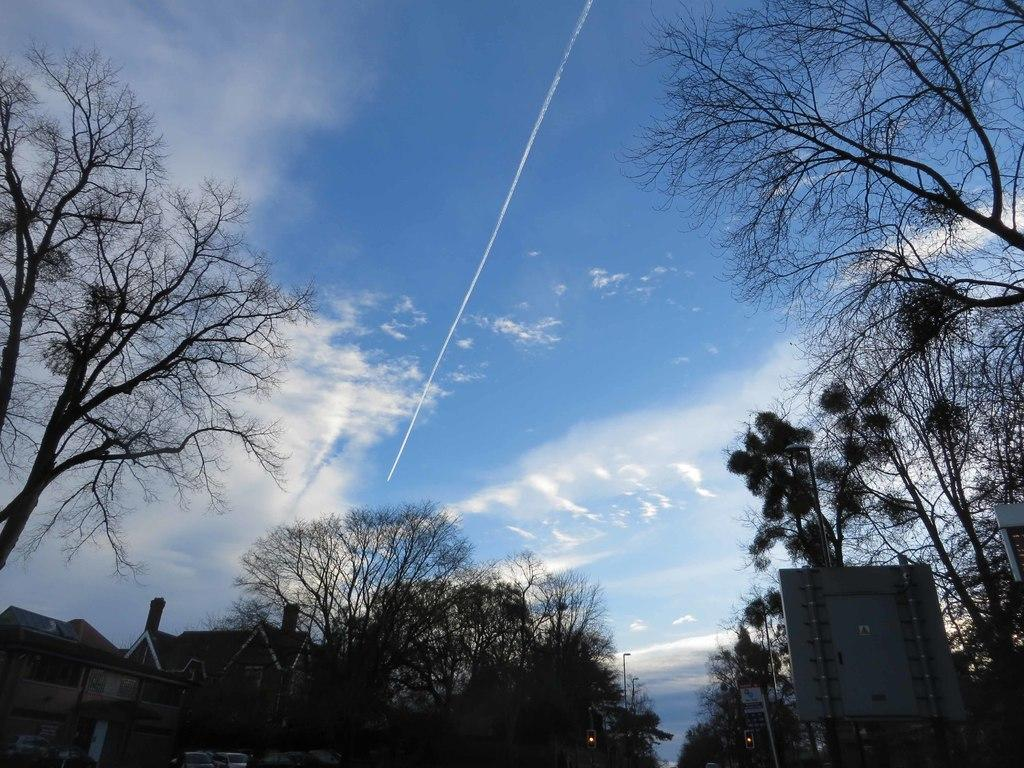What type of vegetation can be seen in the image? There are trees in the image. What type of structure is present in the image? There is a house in the image. What type of lighting is visible in the image? Street lights are visible in the image. What object can be seen in the image that might be used for displaying information or advertisements? There is a board in the image. What can be seen in the background of the image? The sky is visible in the background of the image. What type of knife is being used to cut the pancake in the image? There is no knife or pancake present in the image. Is the band playing a concert in the background of the image? There is no band or concert present in the image. 